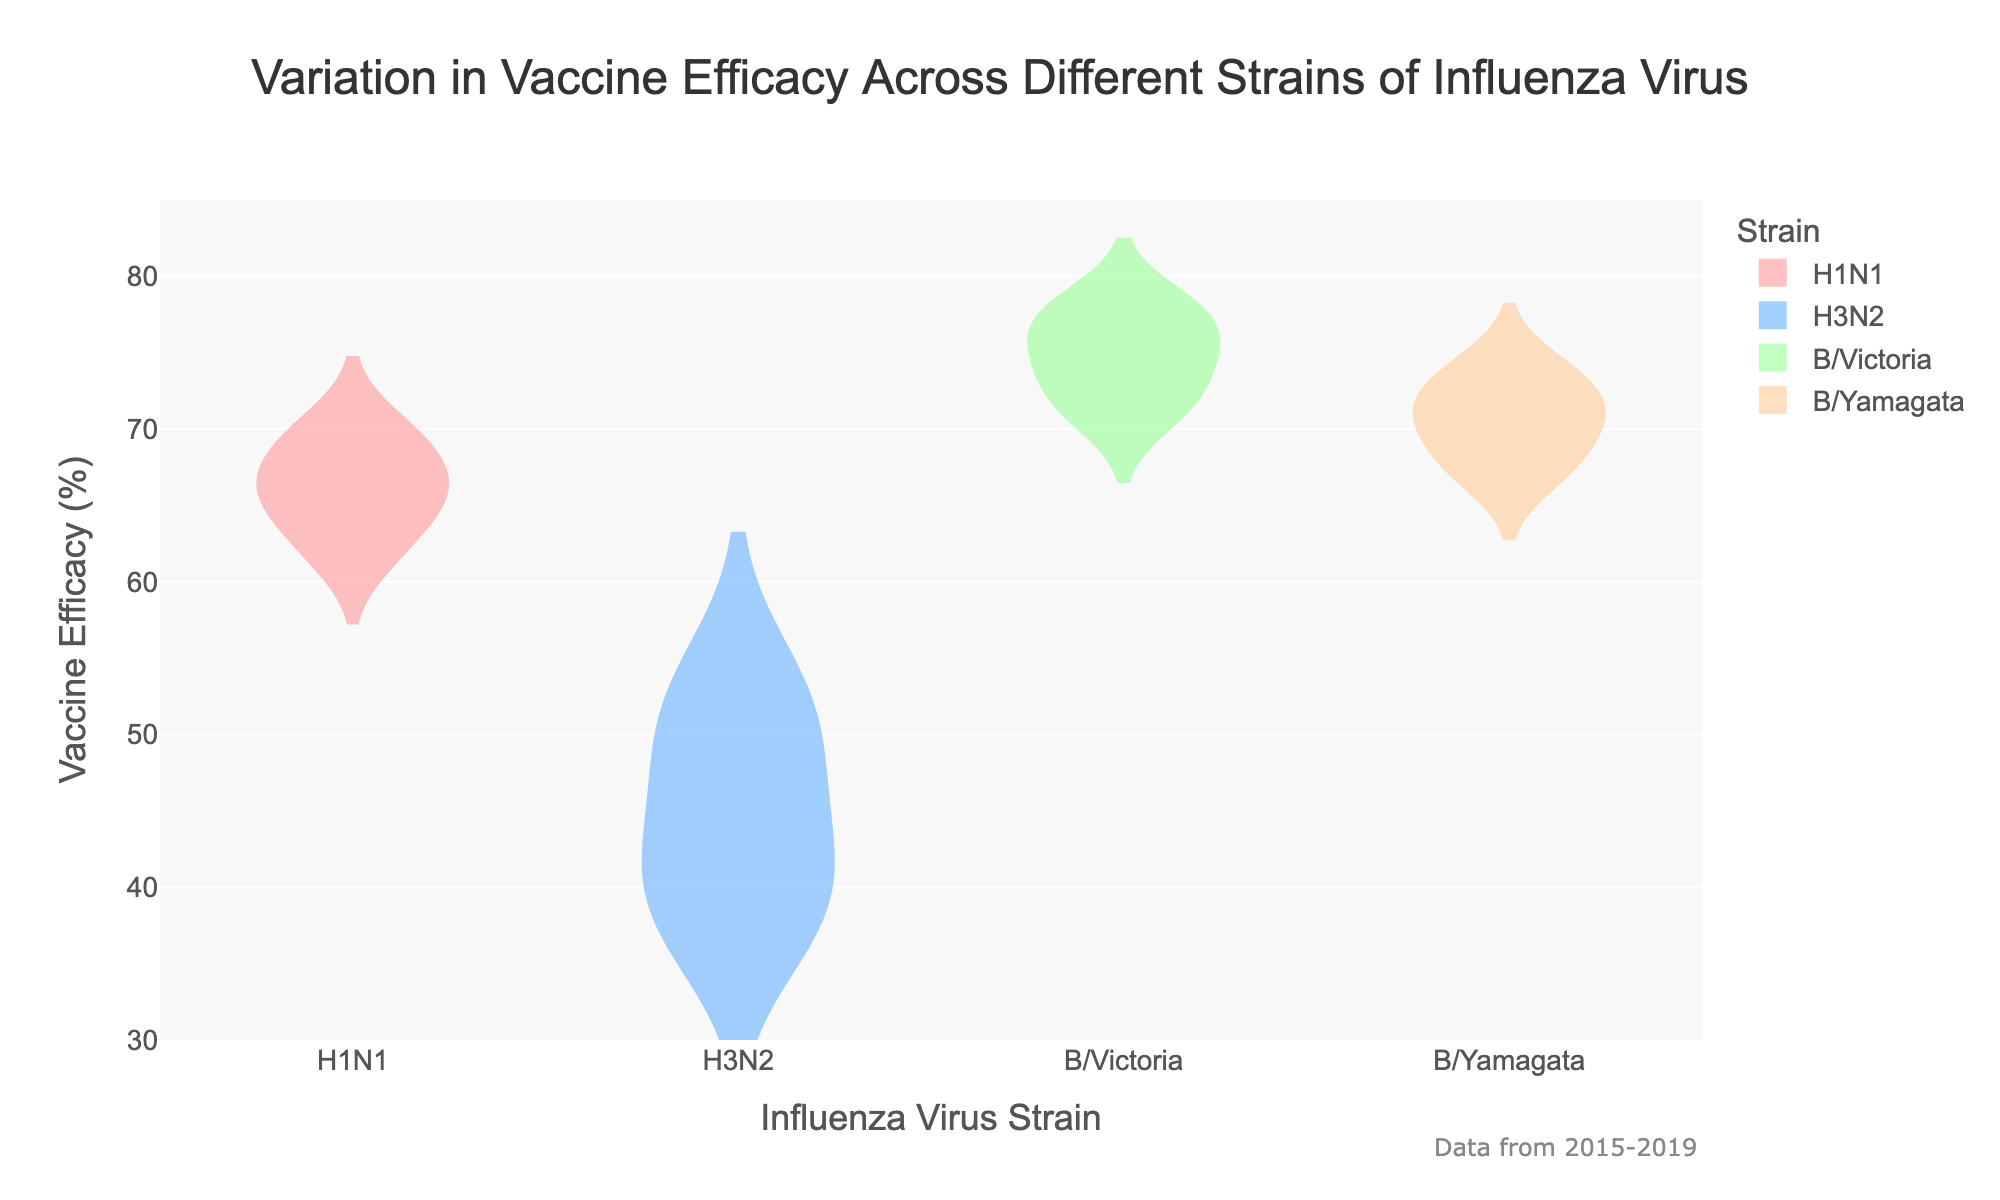What is the title of the figure? The title is prominently displayed at the top of the figure. It is "Variation in Vaccine Efficacy Across Different Strains of Influenza Virus".
Answer: Variation in Vaccine Efficacy Across Different Strains of Influenza Virus Which strain has the highest median vaccine efficacy? To find this, observe the white dot in each violin plot, which represents the median. The highest median appears in the B/Victoria plot.
Answer: B/Victoria How many strains are displayed in the figure? Count the unique categories along the x-axis. There are four different strains shown: H1N1, H3N2, B/Victoria, and B/Yamagata.
Answer: 4 What is the range of vaccine efficacy for the H3N2 strain? The range can be identified by looking at the spread of the data points and the boxplot within the violin plot for H3N2. It spans from 38 to 53 percent.
Answer: 38 to 53 Which strain has the lowest minimum vaccine efficacy? The minimum efficacy is represented by the bottom whisker of the boxplot within the violin plot. The lowest minimum efficacy is seen in the H3N2 strain.
Answer: H3N2 What is the overall trend of vaccine efficacy for the H1N1 strain over the years displayed? Observe the points within the H1N1 violin plot. Over the years 2015-2019, the points fluctuate but remain relatively stable, mostly between 62 and 70 percent.
Answer: Stable with slight variation Compare the variance in vaccine efficacy between H1N1 and H3N2 strains. The spread of the data in the violin plots represents variance. H3N2 shows a broader spread, indicating higher variance, while H1N1 is more compact, indicating lower variance.
Answer: H3N2 has higher variance Which strain has the most consistent vaccine efficacy based on the violin plots? Consistency is indicated by how tight the distribution of the points is. B/Victoria has the tightest distribution, indicating the most consistent efficacy.
Answer: B/Victoria How does the maximum vaccine efficacy for B/Yamagata compare to B/Victoria? Compare the top whiskers of the boxplots within the violin plots. B/Victoria's maximum is slightly higher than B/Yamagata's.
Answer: B/Victoria is higher 